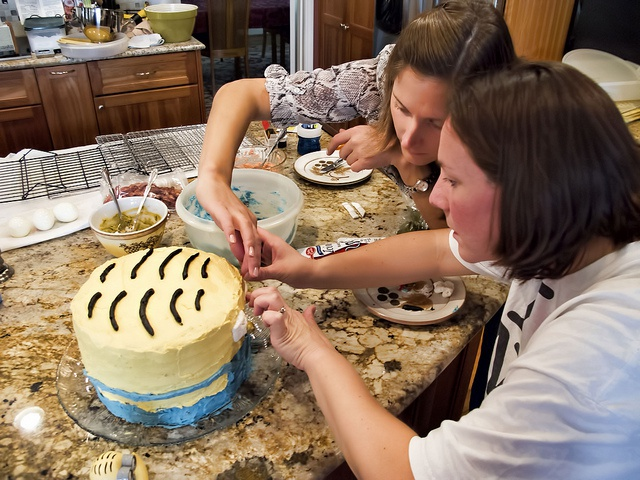Describe the objects in this image and their specific colors. I can see dining table in darkgray, tan, and beige tones, people in darkgray, black, lightgray, and brown tones, people in darkgray, black, maroon, tan, and brown tones, cake in darkgray, khaki, lightyellow, tan, and black tones, and bowl in darkgray, lightgray, and tan tones in this image. 